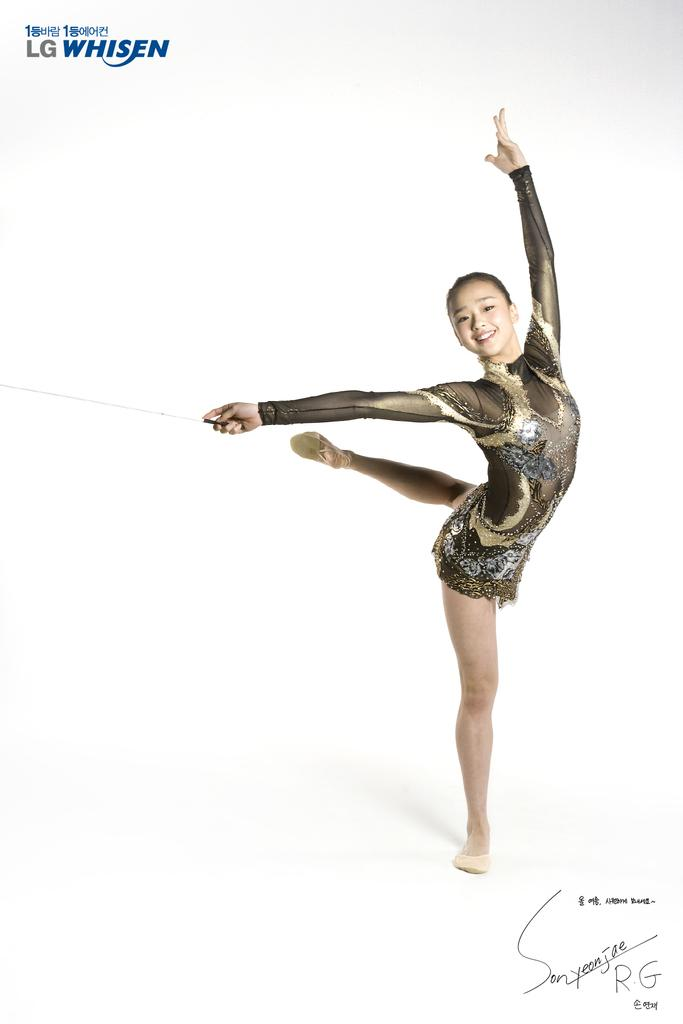Who is the main subject in the image? There is a woman in the image. What is the woman wearing? The woman is wearing a dress. What object is the woman holding in her hand? The woman is holding a stick in her hand. What can be seen in the background of the image? There is text visible in the background of the image. What type of question is being asked at the party in the image? There is no party present in the image, and therefore no questions are being asked. 